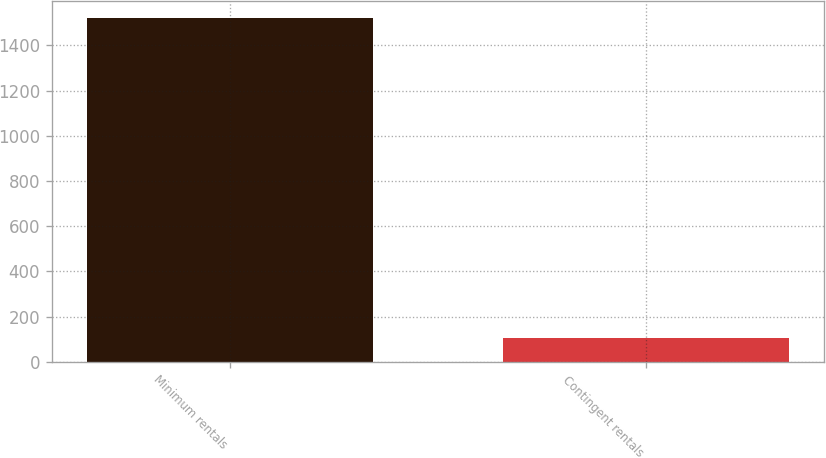<chart> <loc_0><loc_0><loc_500><loc_500><bar_chart><fcel>Minimum rentals<fcel>Contingent rentals<nl><fcel>1522<fcel>107<nl></chart> 